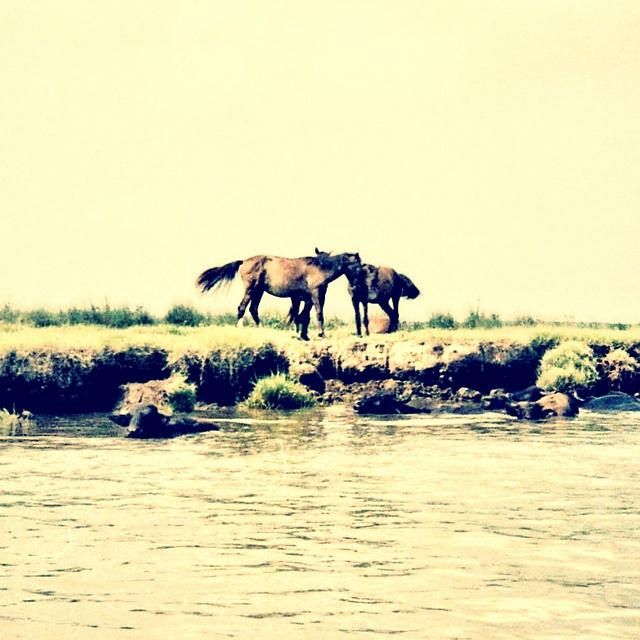How do the horses likely feel towards each other? love 